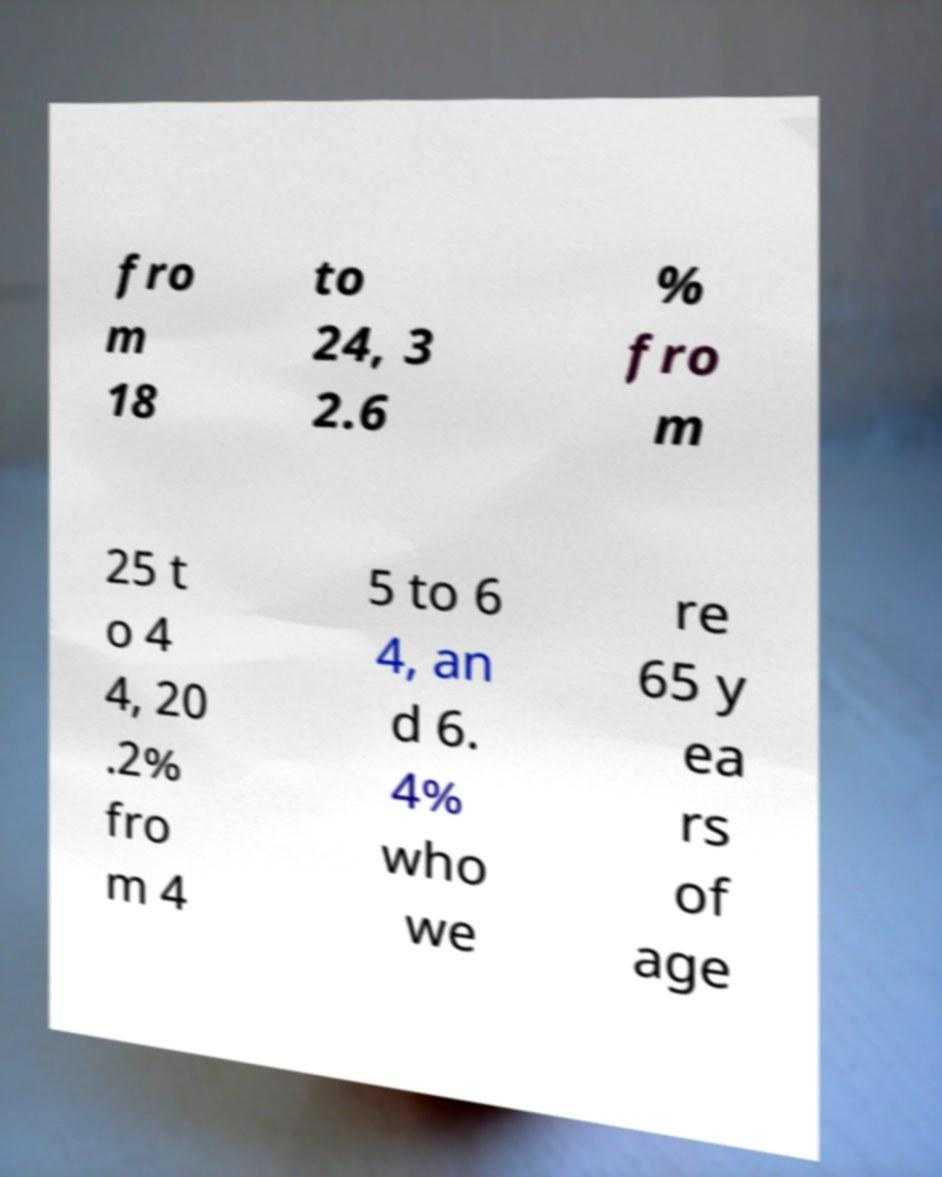Can you read and provide the text displayed in the image?This photo seems to have some interesting text. Can you extract and type it out for me? fro m 18 to 24, 3 2.6 % fro m 25 t o 4 4, 20 .2% fro m 4 5 to 6 4, an d 6. 4% who we re 65 y ea rs of age 